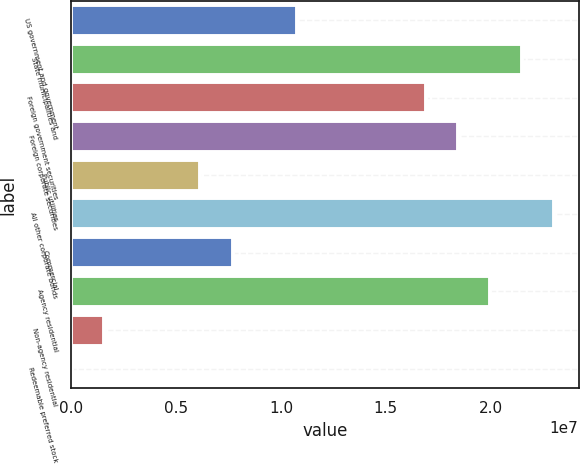Convert chart. <chart><loc_0><loc_0><loc_500><loc_500><bar_chart><fcel>US government and government<fcel>State municipalities and<fcel>Foreign government securities<fcel>Foreign corporate securities<fcel>Public utilities<fcel>All other corporate bonds<fcel>Commercial<fcel>Agency residential<fcel>Non-agency residential<fcel>Redeemable preferred stock<nl><fcel>1.07608e+07<fcel>2.1504e+07<fcel>1.68998e+07<fcel>1.84345e+07<fcel>6.15657e+06<fcel>2.30387e+07<fcel>7.69131e+06<fcel>1.99692e+07<fcel>1.55234e+06<fcel>17603<nl></chart> 